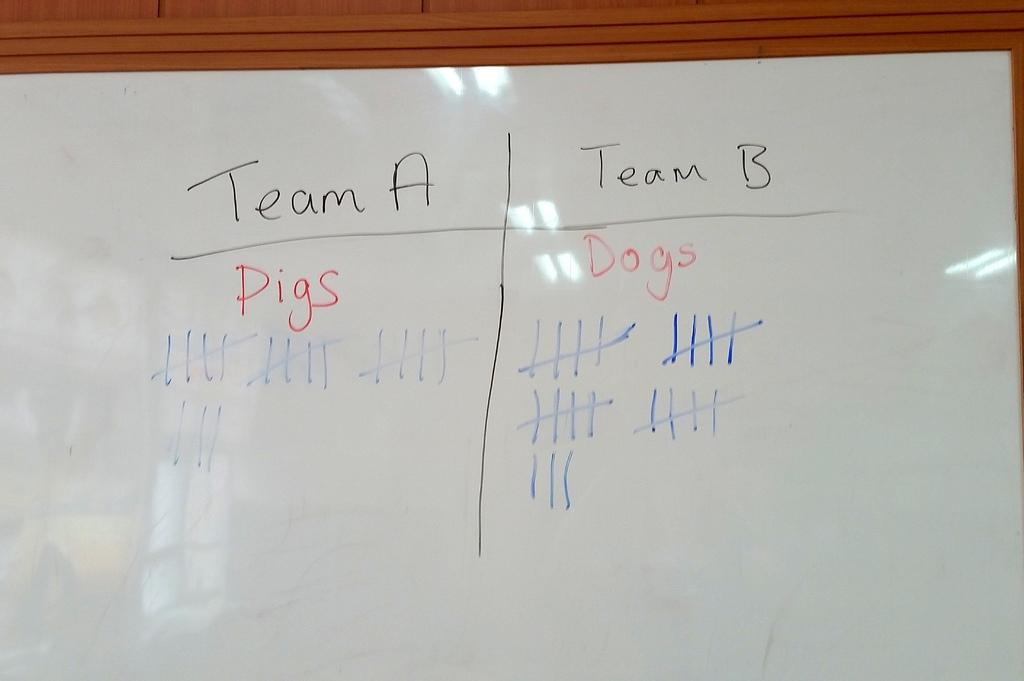What team is winning?
Offer a very short reply. Team b. What are the teams consist of?
Make the answer very short. Pigs and dogs. 